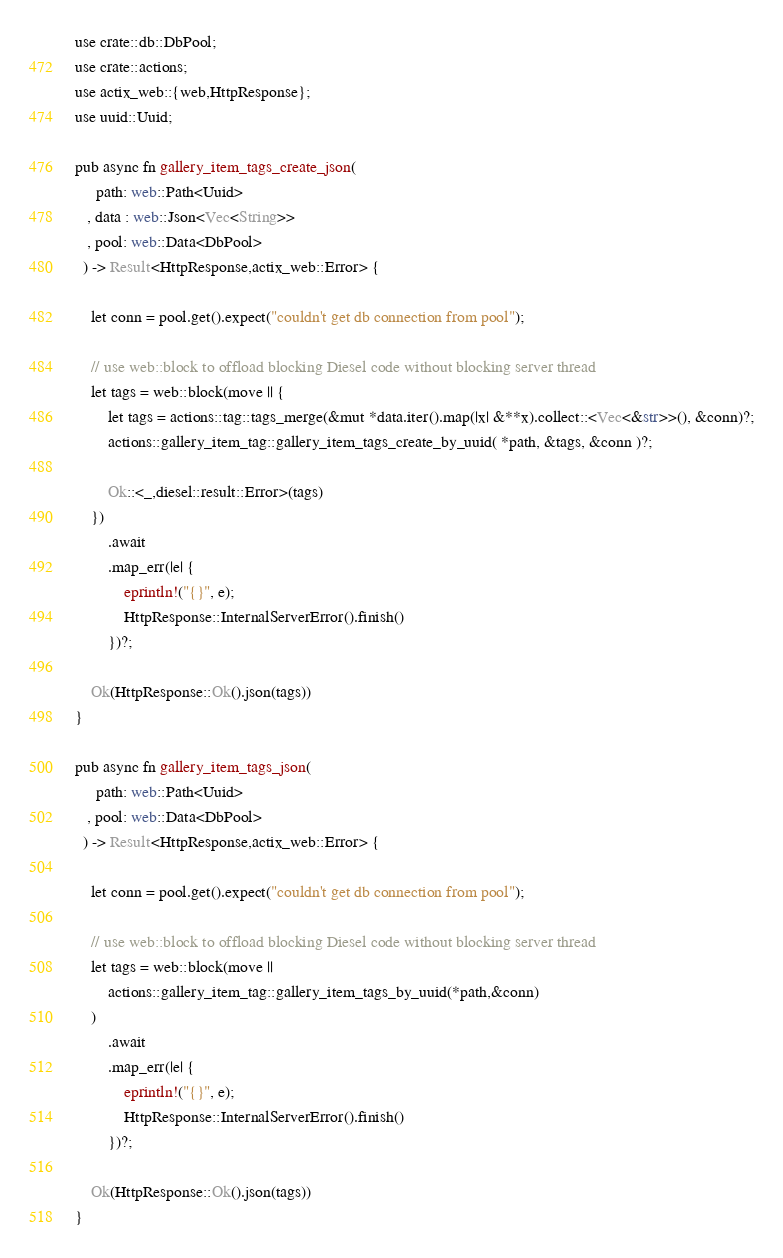<code> <loc_0><loc_0><loc_500><loc_500><_Rust_>
use crate::db::DbPool;
use crate::actions;
use actix_web::{web,HttpResponse};
use uuid::Uuid;

pub async fn gallery_item_tags_create_json(
     path: web::Path<Uuid>
   , data : web::Json<Vec<String>>
   , pool: web::Data<DbPool>
  ) -> Result<HttpResponse,actix_web::Error> {

    let conn = pool.get().expect("couldn't get db connection from pool");

    // use web::block to offload blocking Diesel code without blocking server thread
    let tags = web::block(move || { 
        let tags = actions::tag::tags_merge(&mut *data.iter().map(|x| &**x).collect::<Vec<&str>>(), &conn)?;
        actions::gallery_item_tag::gallery_item_tags_create_by_uuid( *path, &tags, &conn )?;

        Ok::<_,diesel::result::Error>(tags)
    })
        .await
        .map_err(|e| {
            eprintln!("{}", e);
            HttpResponse::InternalServerError().finish()
        })?;

    Ok(HttpResponse::Ok().json(tags))
}

pub async fn gallery_item_tags_json(
     path: web::Path<Uuid>
   , pool: web::Data<DbPool>
  ) -> Result<HttpResponse,actix_web::Error> {

    let conn = pool.get().expect("couldn't get db connection from pool");

    // use web::block to offload blocking Diesel code without blocking server thread
    let tags = web::block(move || 
        actions::gallery_item_tag::gallery_item_tags_by_uuid(*path,&conn)
    )
        .await
        .map_err(|e| {
            eprintln!("{}", e);
            HttpResponse::InternalServerError().finish()
        })?;

    Ok(HttpResponse::Ok().json(tags))
}
</code> 